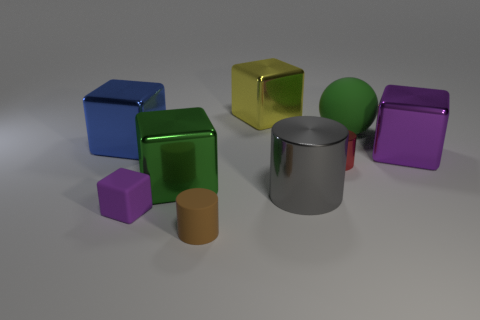Subtract all small purple matte blocks. How many blocks are left? 4 Add 1 small cubes. How many objects exist? 10 Subtract all gray cylinders. How many cylinders are left? 2 Subtract all spheres. How many objects are left? 8 Subtract 2 cylinders. How many cylinders are left? 1 Subtract all gray cubes. How many gray balls are left? 0 Subtract 1 blue cubes. How many objects are left? 8 Subtract all purple spheres. Subtract all purple cubes. How many spheres are left? 1 Subtract all large blue things. Subtract all large matte things. How many objects are left? 7 Add 9 gray shiny cylinders. How many gray shiny cylinders are left? 10 